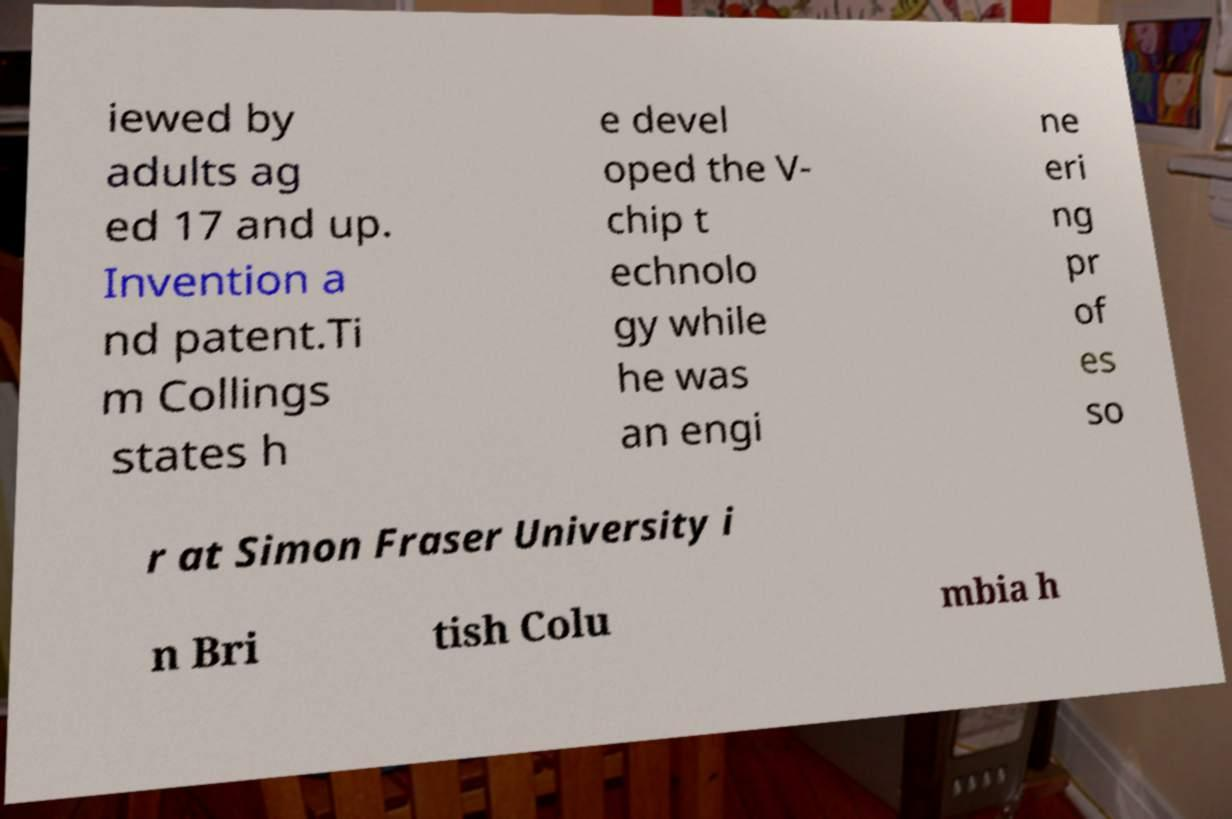What messages or text are displayed in this image? I need them in a readable, typed format. iewed by adults ag ed 17 and up. Invention a nd patent.Ti m Collings states h e devel oped the V- chip t echnolo gy while he was an engi ne eri ng pr of es so r at Simon Fraser University i n Bri tish Colu mbia h 